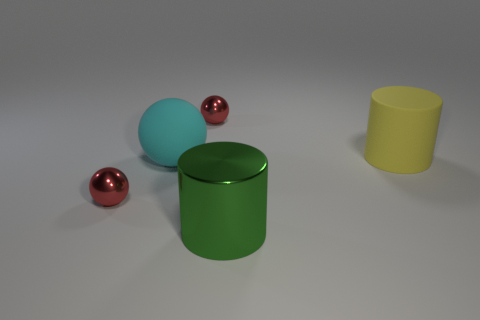Add 2 tiny cylinders. How many objects exist? 7 Subtract all cylinders. How many objects are left? 3 Add 4 matte things. How many matte things exist? 6 Subtract 0 gray blocks. How many objects are left? 5 Subtract all big yellow metal balls. Subtract all yellow rubber cylinders. How many objects are left? 4 Add 3 large cylinders. How many large cylinders are left? 5 